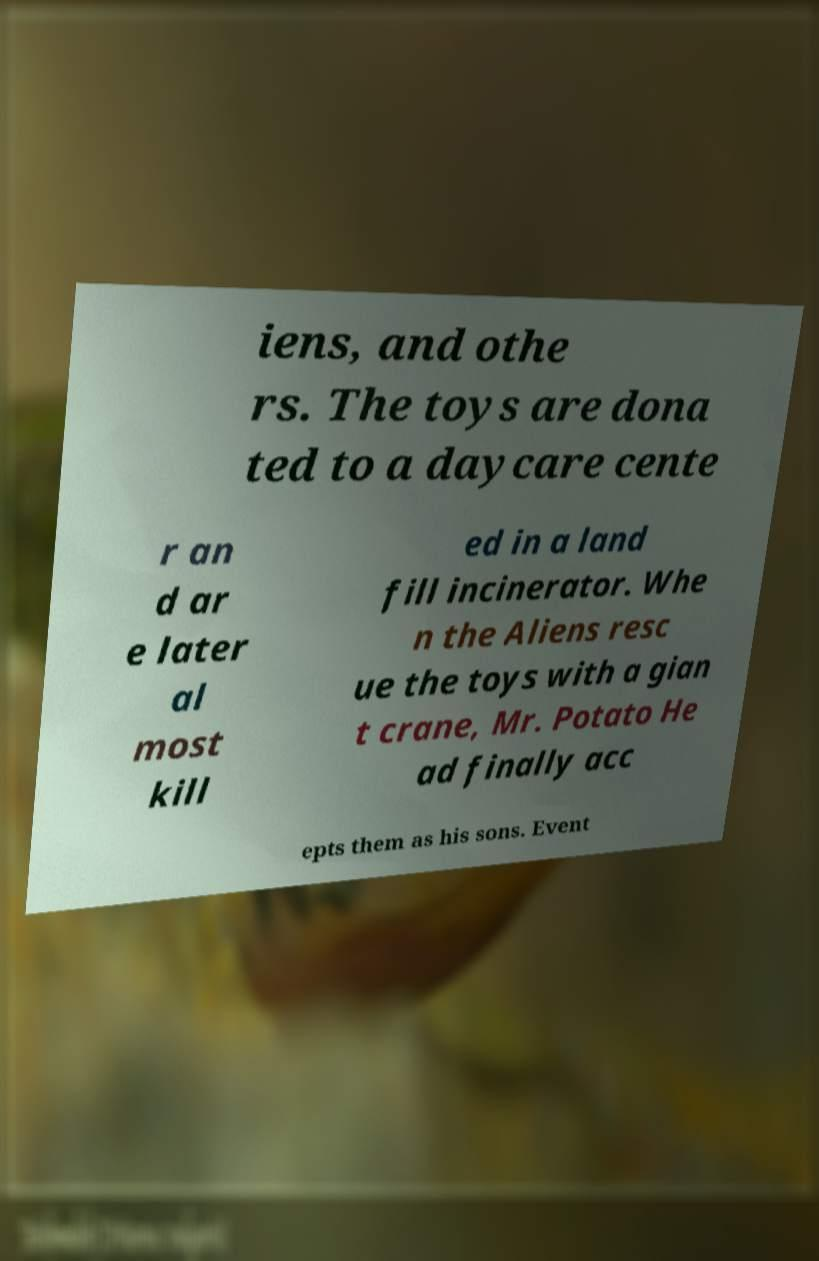There's text embedded in this image that I need extracted. Can you transcribe it verbatim? iens, and othe rs. The toys are dona ted to a daycare cente r an d ar e later al most kill ed in a land fill incinerator. Whe n the Aliens resc ue the toys with a gian t crane, Mr. Potato He ad finally acc epts them as his sons. Event 